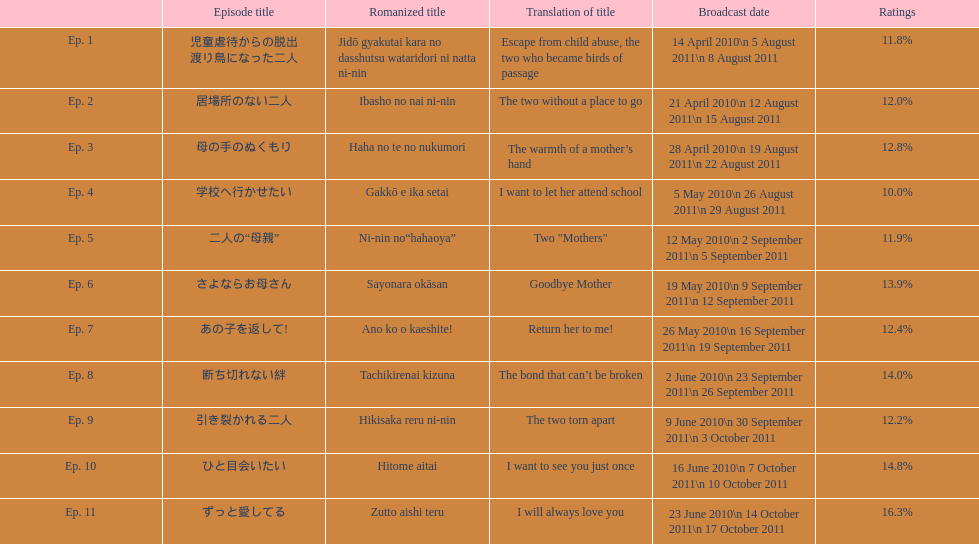What as the percentage total of ratings for episode 8? 14.0%. Help me parse the entirety of this table. {'header': ['', 'Episode title', 'Romanized title', 'Translation of title', 'Broadcast date', 'Ratings'], 'rows': [['Ep. 1', '児童虐待からの脱出 渡り鳥になった二人', 'Jidō gyakutai kara no dasshutsu wataridori ni natta ni-nin', 'Escape from child abuse, the two who became birds of passage', '14 April 2010\\n 5 August 2011\\n 8 August 2011', '11.8%'], ['Ep. 2', '居場所のない二人', 'Ibasho no nai ni-nin', 'The two without a place to go', '21 April 2010\\n 12 August 2011\\n 15 August 2011', '12.0%'], ['Ep. 3', '母の手のぬくもり', 'Haha no te no nukumori', 'The warmth of a mother’s hand', '28 April 2010\\n 19 August 2011\\n 22 August 2011', '12.8%'], ['Ep. 4', '学校へ行かせたい', 'Gakkō e ika setai', 'I want to let her attend school', '5 May 2010\\n 26 August 2011\\n 29 August 2011', '10.0%'], ['Ep. 5', '二人の“母親”', 'Ni-nin no“hahaoya”', 'Two "Mothers"', '12 May 2010\\n 2 September 2011\\n 5 September 2011', '11.9%'], ['Ep. 6', 'さよならお母さん', 'Sayonara okāsan', 'Goodbye Mother', '19 May 2010\\n 9 September 2011\\n 12 September 2011', '13.9%'], ['Ep. 7', 'あの子を返して!', 'Ano ko o kaeshite!', 'Return her to me!', '26 May 2010\\n 16 September 2011\\n 19 September 2011', '12.4%'], ['Ep. 8', '断ち切れない絆', 'Tachikirenai kizuna', 'The bond that can’t be broken', '2 June 2010\\n 23 September 2011\\n 26 September 2011', '14.0%'], ['Ep. 9', '引き裂かれる二人', 'Hikisaka reru ni-nin', 'The two torn apart', '9 June 2010\\n 30 September 2011\\n 3 October 2011', '12.2%'], ['Ep. 10', 'ひと目会いたい', 'Hitome aitai', 'I want to see you just once', '16 June 2010\\n 7 October 2011\\n 10 October 2011', '14.8%'], ['Ep. 11', 'ずっと愛してる', 'Zutto aishi teru', 'I will always love you', '23 June 2010\\n 14 October 2011\\n 17 October 2011', '16.3%']]} 